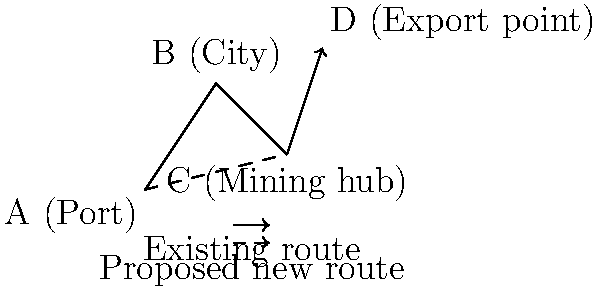Based on the vector map showing commodity trade routes in Africa, which proposed infrastructure improvement would likely have the greatest impact on reducing transportation costs and time for commodity exports? To answer this question, we need to analyze the existing and proposed trade routes shown in the vector map:

1. Existing route: A (Port) → B (City) → C (Mining hub) → D (Export point)
2. Proposed new route: A (Port) → C (Mining hub) → D (Export point)

Step-by-step analysis:
1. The existing route involves four points: A, B, C, and D.
2. The proposed new route bypasses point B (City), creating a direct connection between A (Port) and C (Mining hub).
3. By eliminating the detour through point B, the proposed route shortens the overall distance traveled.
4. A shorter route generally leads to reduced transportation time and costs.
5. The direct connection between the port (A) and the mining hub (C) allows for more efficient movement of commodities from their source to the export point (D).
6. This improvement particularly benefits the mining sector, which is a crucial part of many African economies.

The proposed infrastructure improvement that would have the greatest impact on reducing transportation costs and time for commodity exports is the direct connection between the port (A) and the mining hub (C), bypassing the city (B).
Answer: Direct port-to-mining hub connection 